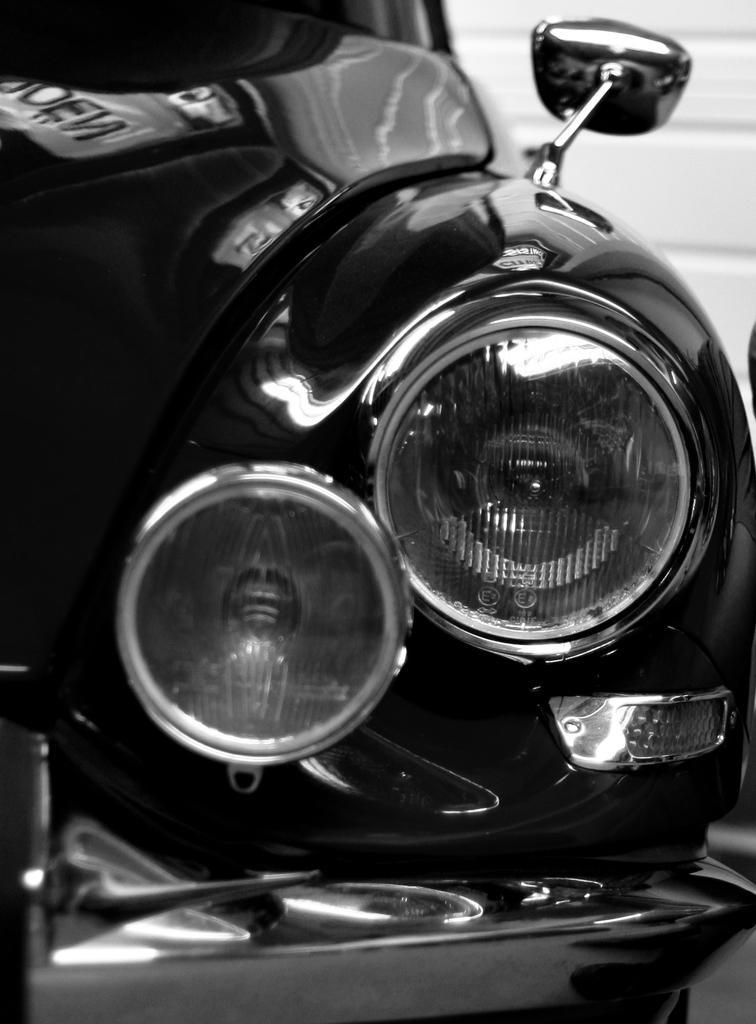How would you summarize this image in a sentence or two? In this picture I can see a car and I can see headlights, front bumper and a side mirror and looks like a wall in the background. 